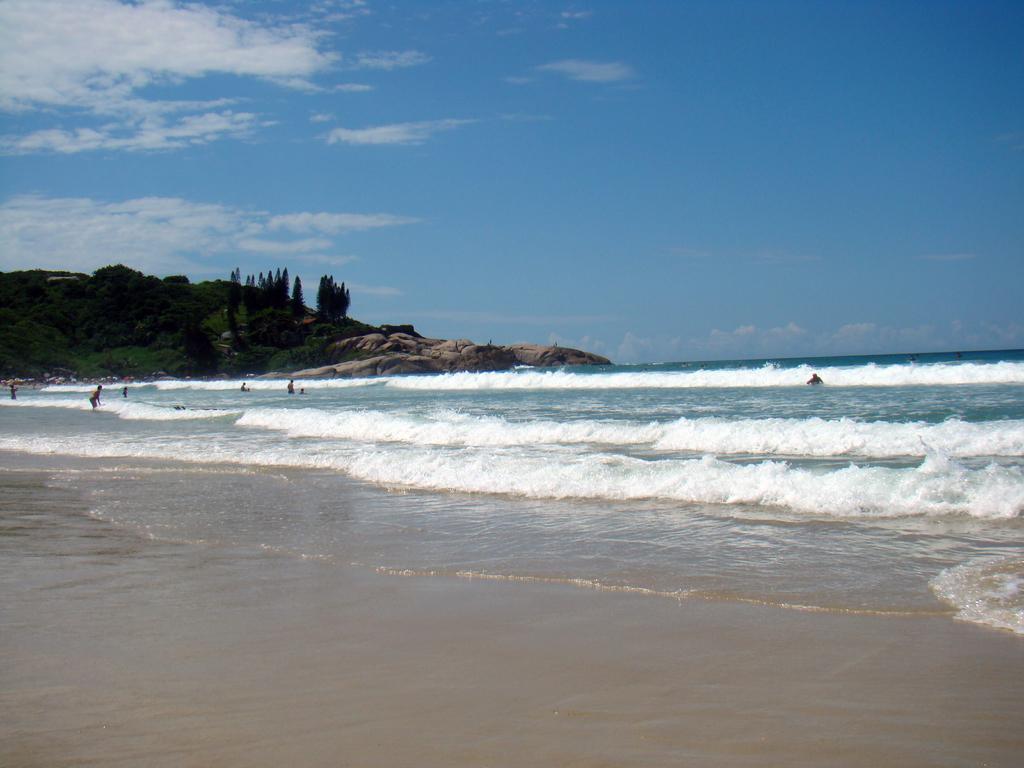Please provide a concise description of this image. This image is taken outdoors. At the top of the image there is a sky with clouds. At the bottom of the image there is a ground. In the middle of the image there is a sea with waves and a few people are playing in the sea. On the left side of the image there is a hill and there are a few trees plants and trees on the hill. 